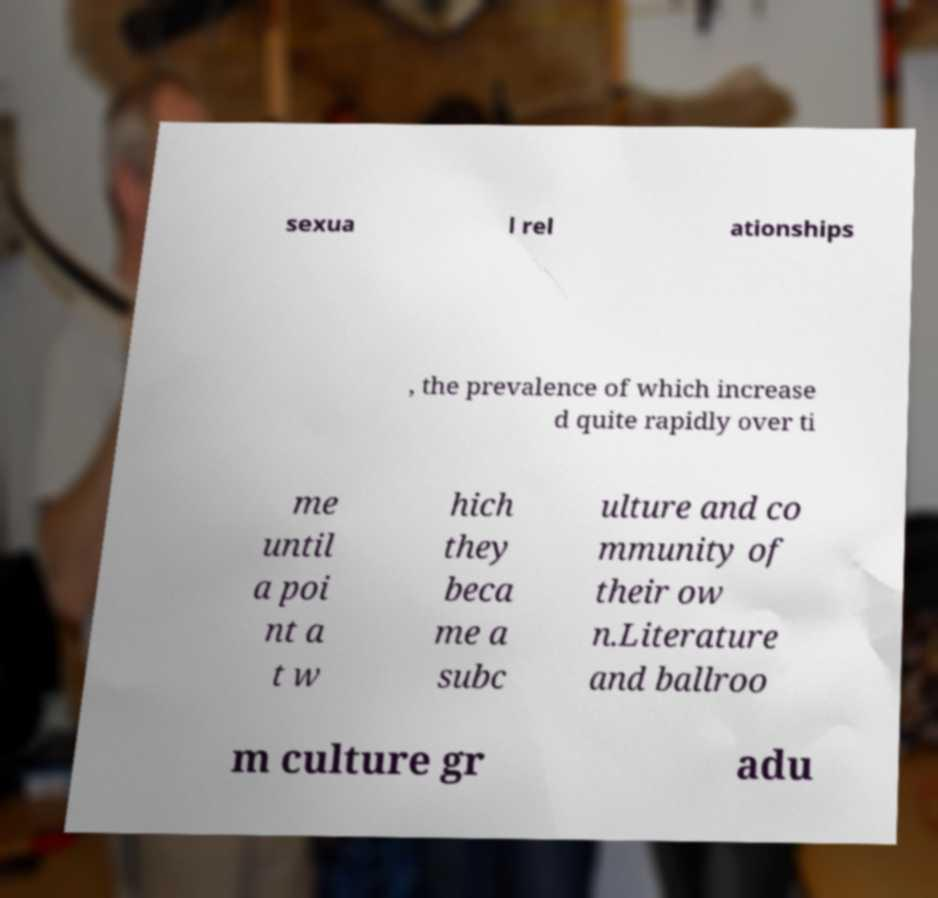Can you read and provide the text displayed in the image?This photo seems to have some interesting text. Can you extract and type it out for me? sexua l rel ationships , the prevalence of which increase d quite rapidly over ti me until a poi nt a t w hich they beca me a subc ulture and co mmunity of their ow n.Literature and ballroo m culture gr adu 